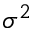<formula> <loc_0><loc_0><loc_500><loc_500>\sigma ^ { 2 }</formula> 